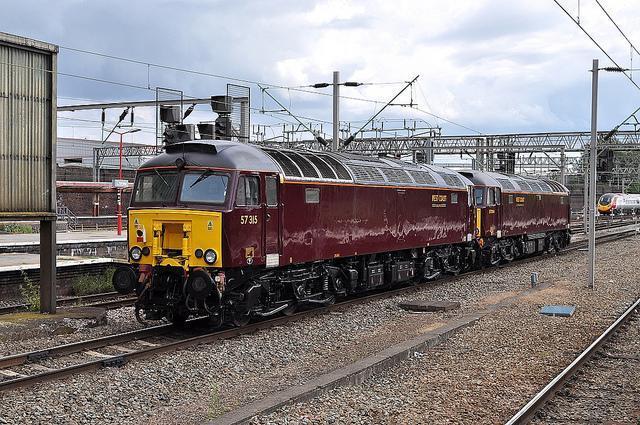How many train cars can be seen?
Give a very brief answer. 2. How many of the people on the bench are holding umbrellas ?
Give a very brief answer. 0. 